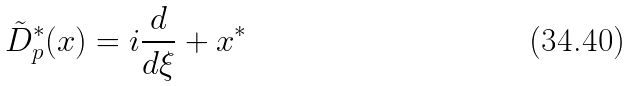<formula> <loc_0><loc_0><loc_500><loc_500>\tilde { D } _ { p } ^ { \ast } ( x ) = i \frac { d } { d \xi } + x ^ { \ast }</formula> 